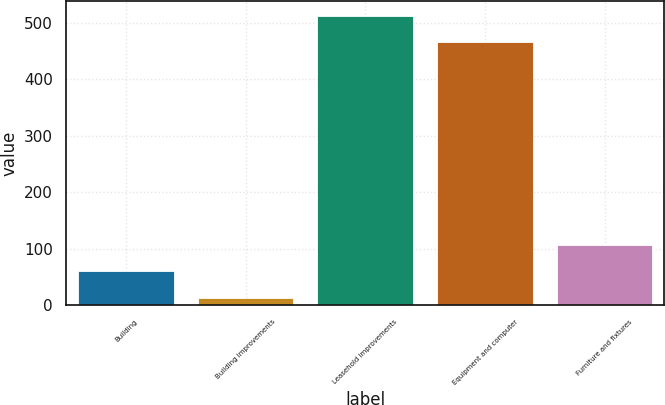Convert chart to OTSL. <chart><loc_0><loc_0><loc_500><loc_500><bar_chart><fcel>Building<fcel>Building improvements<fcel>Leasehold improvements<fcel>Equipment and computer<fcel>Furniture and fixtures<nl><fcel>59.9<fcel>13<fcel>511.9<fcel>465<fcel>106.8<nl></chart> 